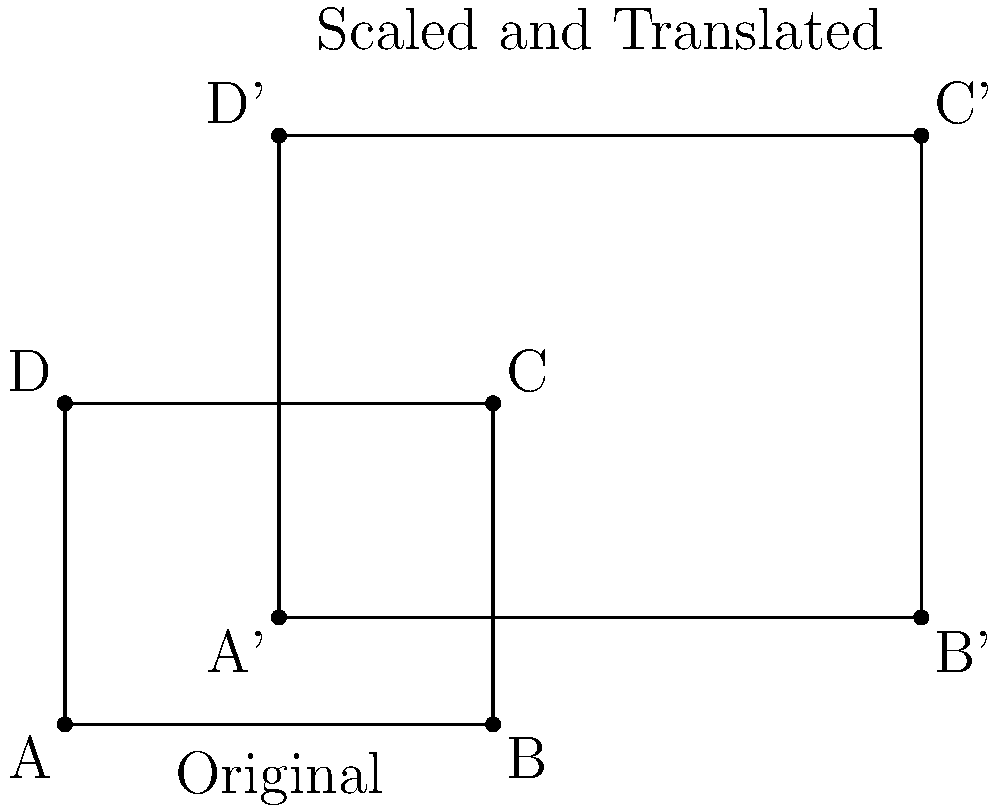In an investigation of property blueprint manipulation, you've discovered that a suspect has scaled and translated a original rectangular property blueprint. The original blueprint had dimensions of 4 units by 3 units. After transformation, point A (0,0) moved to (2,1), and point B (4,0) moved to (8,1). Determine the scale factor used in this transformation and calculate the new area of the property in square units. Let's approach this step-by-step:

1) First, let's determine the scale factor:
   - The original width was 4 units (from A to B)
   - The new width is 6 units (from A' to B')
   - Scale factor = new width / original width = 6/4 = 1.5

2) We can verify this with the height:
   - Original height: 3 units
   - New height: 4.5 units (from A' to D')
   - 4.5 / 3 = 1.5, confirming our scale factor

3) Now, let's calculate the new area:
   - Original area = 4 * 3 = 12 square units
   - When we scale a 2D shape, the area is affected by the square of the scale factor
   - New area = Original area * (scale factor)^2
   - New area = 12 * (1.5)^2 = 12 * 2.25 = 27 square units

Therefore, the scale factor is 1.5, and the new area is 27 square units.
Answer: Scale factor: 1.5, New area: 27 square units 